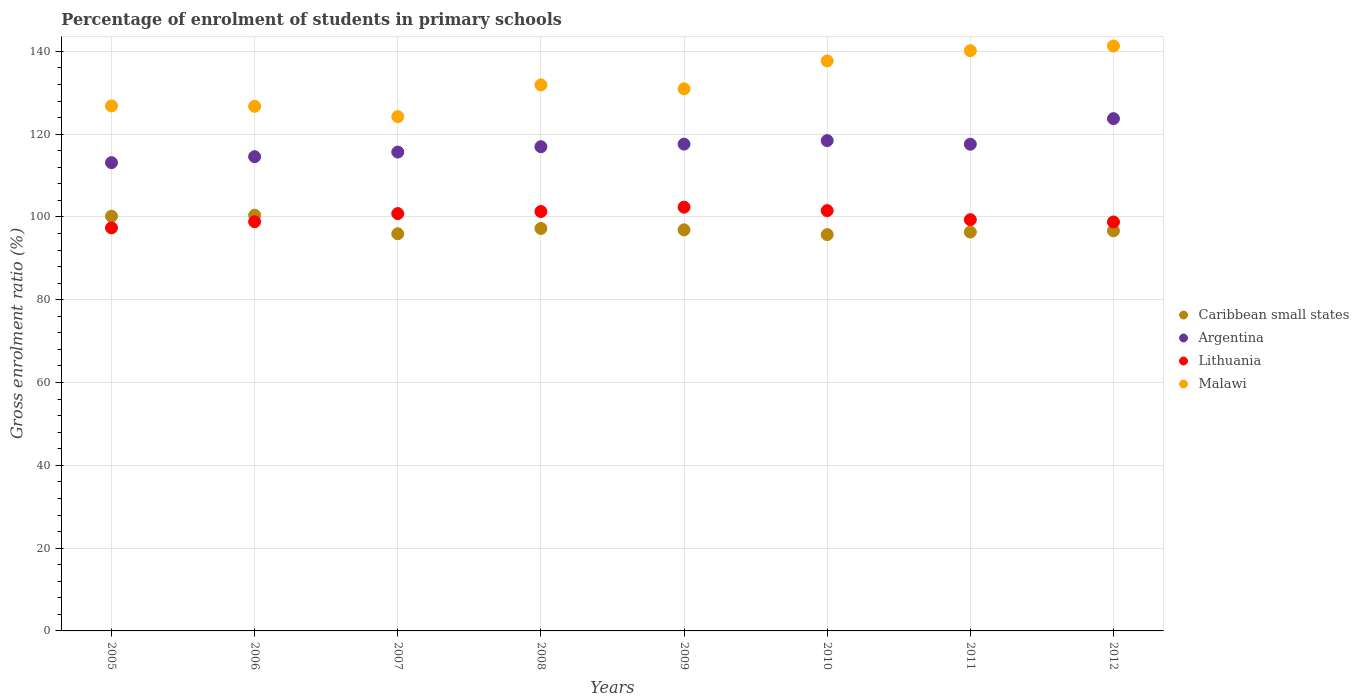What is the percentage of students enrolled in primary schools in Malawi in 2012?
Give a very brief answer. 141.29. Across all years, what is the maximum percentage of students enrolled in primary schools in Argentina?
Your response must be concise. 123.75. Across all years, what is the minimum percentage of students enrolled in primary schools in Malawi?
Keep it short and to the point. 124.23. What is the total percentage of students enrolled in primary schools in Malawi in the graph?
Your answer should be very brief. 1059.76. What is the difference between the percentage of students enrolled in primary schools in Malawi in 2005 and that in 2011?
Provide a succinct answer. -13.33. What is the difference between the percentage of students enrolled in primary schools in Lithuania in 2009 and the percentage of students enrolled in primary schools in Malawi in 2008?
Your answer should be compact. -29.54. What is the average percentage of students enrolled in primary schools in Argentina per year?
Keep it short and to the point. 117.21. In the year 2012, what is the difference between the percentage of students enrolled in primary schools in Lithuania and percentage of students enrolled in primary schools in Malawi?
Keep it short and to the point. -42.51. In how many years, is the percentage of students enrolled in primary schools in Argentina greater than 84 %?
Offer a terse response. 8. What is the ratio of the percentage of students enrolled in primary schools in Caribbean small states in 2009 to that in 2010?
Give a very brief answer. 1.01. What is the difference between the highest and the second highest percentage of students enrolled in primary schools in Caribbean small states?
Make the answer very short. 0.23. What is the difference between the highest and the lowest percentage of students enrolled in primary schools in Malawi?
Ensure brevity in your answer.  17.06. Is it the case that in every year, the sum of the percentage of students enrolled in primary schools in Malawi and percentage of students enrolled in primary schools in Caribbean small states  is greater than the sum of percentage of students enrolled in primary schools in Argentina and percentage of students enrolled in primary schools in Lithuania?
Make the answer very short. No. Is the percentage of students enrolled in primary schools in Lithuania strictly greater than the percentage of students enrolled in primary schools in Malawi over the years?
Give a very brief answer. No. How many years are there in the graph?
Make the answer very short. 8. What is the difference between two consecutive major ticks on the Y-axis?
Ensure brevity in your answer.  20. Where does the legend appear in the graph?
Provide a succinct answer. Center right. How many legend labels are there?
Keep it short and to the point. 4. How are the legend labels stacked?
Offer a terse response. Vertical. What is the title of the graph?
Your answer should be compact. Percentage of enrolment of students in primary schools. What is the Gross enrolment ratio (%) in Caribbean small states in 2005?
Provide a short and direct response. 100.18. What is the Gross enrolment ratio (%) of Argentina in 2005?
Keep it short and to the point. 113.11. What is the Gross enrolment ratio (%) in Lithuania in 2005?
Your response must be concise. 97.36. What is the Gross enrolment ratio (%) of Malawi in 2005?
Provide a short and direct response. 126.82. What is the Gross enrolment ratio (%) in Caribbean small states in 2006?
Provide a short and direct response. 100.41. What is the Gross enrolment ratio (%) in Argentina in 2006?
Your response must be concise. 114.55. What is the Gross enrolment ratio (%) of Lithuania in 2006?
Your answer should be very brief. 98.85. What is the Gross enrolment ratio (%) of Malawi in 2006?
Offer a very short reply. 126.73. What is the Gross enrolment ratio (%) of Caribbean small states in 2007?
Your answer should be compact. 95.94. What is the Gross enrolment ratio (%) of Argentina in 2007?
Your answer should be very brief. 115.67. What is the Gross enrolment ratio (%) of Lithuania in 2007?
Make the answer very short. 100.81. What is the Gross enrolment ratio (%) in Malawi in 2007?
Your answer should be compact. 124.23. What is the Gross enrolment ratio (%) of Caribbean small states in 2008?
Make the answer very short. 97.22. What is the Gross enrolment ratio (%) in Argentina in 2008?
Keep it short and to the point. 116.96. What is the Gross enrolment ratio (%) in Lithuania in 2008?
Give a very brief answer. 101.31. What is the Gross enrolment ratio (%) in Malawi in 2008?
Give a very brief answer. 131.9. What is the Gross enrolment ratio (%) of Caribbean small states in 2009?
Your answer should be very brief. 96.88. What is the Gross enrolment ratio (%) of Argentina in 2009?
Your response must be concise. 117.59. What is the Gross enrolment ratio (%) in Lithuania in 2009?
Provide a short and direct response. 102.36. What is the Gross enrolment ratio (%) in Malawi in 2009?
Your answer should be compact. 130.95. What is the Gross enrolment ratio (%) in Caribbean small states in 2010?
Provide a short and direct response. 95.74. What is the Gross enrolment ratio (%) in Argentina in 2010?
Provide a succinct answer. 118.43. What is the Gross enrolment ratio (%) of Lithuania in 2010?
Keep it short and to the point. 101.52. What is the Gross enrolment ratio (%) in Malawi in 2010?
Make the answer very short. 137.69. What is the Gross enrolment ratio (%) of Caribbean small states in 2011?
Your answer should be very brief. 96.34. What is the Gross enrolment ratio (%) of Argentina in 2011?
Your answer should be very brief. 117.57. What is the Gross enrolment ratio (%) in Lithuania in 2011?
Your answer should be compact. 99.33. What is the Gross enrolment ratio (%) of Malawi in 2011?
Offer a very short reply. 140.15. What is the Gross enrolment ratio (%) of Caribbean small states in 2012?
Offer a very short reply. 96.65. What is the Gross enrolment ratio (%) of Argentina in 2012?
Give a very brief answer. 123.75. What is the Gross enrolment ratio (%) of Lithuania in 2012?
Keep it short and to the point. 98.78. What is the Gross enrolment ratio (%) of Malawi in 2012?
Your response must be concise. 141.29. Across all years, what is the maximum Gross enrolment ratio (%) of Caribbean small states?
Your answer should be compact. 100.41. Across all years, what is the maximum Gross enrolment ratio (%) in Argentina?
Give a very brief answer. 123.75. Across all years, what is the maximum Gross enrolment ratio (%) of Lithuania?
Offer a terse response. 102.36. Across all years, what is the maximum Gross enrolment ratio (%) of Malawi?
Offer a very short reply. 141.29. Across all years, what is the minimum Gross enrolment ratio (%) in Caribbean small states?
Your answer should be very brief. 95.74. Across all years, what is the minimum Gross enrolment ratio (%) in Argentina?
Give a very brief answer. 113.11. Across all years, what is the minimum Gross enrolment ratio (%) in Lithuania?
Offer a very short reply. 97.36. Across all years, what is the minimum Gross enrolment ratio (%) of Malawi?
Provide a succinct answer. 124.23. What is the total Gross enrolment ratio (%) in Caribbean small states in the graph?
Your answer should be compact. 779.36. What is the total Gross enrolment ratio (%) in Argentina in the graph?
Your answer should be very brief. 937.64. What is the total Gross enrolment ratio (%) in Lithuania in the graph?
Your answer should be compact. 800.33. What is the total Gross enrolment ratio (%) in Malawi in the graph?
Keep it short and to the point. 1059.76. What is the difference between the Gross enrolment ratio (%) of Caribbean small states in 2005 and that in 2006?
Offer a terse response. -0.23. What is the difference between the Gross enrolment ratio (%) of Argentina in 2005 and that in 2006?
Your answer should be compact. -1.44. What is the difference between the Gross enrolment ratio (%) in Lithuania in 2005 and that in 2006?
Give a very brief answer. -1.49. What is the difference between the Gross enrolment ratio (%) of Malawi in 2005 and that in 2006?
Make the answer very short. 0.09. What is the difference between the Gross enrolment ratio (%) of Caribbean small states in 2005 and that in 2007?
Provide a short and direct response. 4.24. What is the difference between the Gross enrolment ratio (%) of Argentina in 2005 and that in 2007?
Your answer should be compact. -2.56. What is the difference between the Gross enrolment ratio (%) of Lithuania in 2005 and that in 2007?
Make the answer very short. -3.45. What is the difference between the Gross enrolment ratio (%) in Malawi in 2005 and that in 2007?
Your response must be concise. 2.59. What is the difference between the Gross enrolment ratio (%) in Caribbean small states in 2005 and that in 2008?
Offer a terse response. 2.96. What is the difference between the Gross enrolment ratio (%) in Argentina in 2005 and that in 2008?
Offer a very short reply. -3.85. What is the difference between the Gross enrolment ratio (%) in Lithuania in 2005 and that in 2008?
Provide a short and direct response. -3.95. What is the difference between the Gross enrolment ratio (%) of Malawi in 2005 and that in 2008?
Keep it short and to the point. -5.08. What is the difference between the Gross enrolment ratio (%) of Caribbean small states in 2005 and that in 2009?
Offer a terse response. 3.3. What is the difference between the Gross enrolment ratio (%) of Argentina in 2005 and that in 2009?
Your answer should be compact. -4.48. What is the difference between the Gross enrolment ratio (%) of Lithuania in 2005 and that in 2009?
Ensure brevity in your answer.  -5. What is the difference between the Gross enrolment ratio (%) in Malawi in 2005 and that in 2009?
Ensure brevity in your answer.  -4.13. What is the difference between the Gross enrolment ratio (%) of Caribbean small states in 2005 and that in 2010?
Make the answer very short. 4.44. What is the difference between the Gross enrolment ratio (%) in Argentina in 2005 and that in 2010?
Make the answer very short. -5.32. What is the difference between the Gross enrolment ratio (%) in Lithuania in 2005 and that in 2010?
Your answer should be very brief. -4.16. What is the difference between the Gross enrolment ratio (%) of Malawi in 2005 and that in 2010?
Provide a succinct answer. -10.87. What is the difference between the Gross enrolment ratio (%) in Caribbean small states in 2005 and that in 2011?
Give a very brief answer. 3.84. What is the difference between the Gross enrolment ratio (%) of Argentina in 2005 and that in 2011?
Your response must be concise. -4.45. What is the difference between the Gross enrolment ratio (%) in Lithuania in 2005 and that in 2011?
Ensure brevity in your answer.  -1.97. What is the difference between the Gross enrolment ratio (%) in Malawi in 2005 and that in 2011?
Give a very brief answer. -13.33. What is the difference between the Gross enrolment ratio (%) of Caribbean small states in 2005 and that in 2012?
Ensure brevity in your answer.  3.53. What is the difference between the Gross enrolment ratio (%) of Argentina in 2005 and that in 2012?
Provide a succinct answer. -10.64. What is the difference between the Gross enrolment ratio (%) of Lithuania in 2005 and that in 2012?
Your response must be concise. -1.42. What is the difference between the Gross enrolment ratio (%) in Malawi in 2005 and that in 2012?
Your response must be concise. -14.47. What is the difference between the Gross enrolment ratio (%) in Caribbean small states in 2006 and that in 2007?
Provide a short and direct response. 4.47. What is the difference between the Gross enrolment ratio (%) of Argentina in 2006 and that in 2007?
Keep it short and to the point. -1.12. What is the difference between the Gross enrolment ratio (%) in Lithuania in 2006 and that in 2007?
Make the answer very short. -1.96. What is the difference between the Gross enrolment ratio (%) of Malawi in 2006 and that in 2007?
Keep it short and to the point. 2.5. What is the difference between the Gross enrolment ratio (%) in Caribbean small states in 2006 and that in 2008?
Make the answer very short. 3.19. What is the difference between the Gross enrolment ratio (%) in Argentina in 2006 and that in 2008?
Your answer should be compact. -2.41. What is the difference between the Gross enrolment ratio (%) of Lithuania in 2006 and that in 2008?
Provide a short and direct response. -2.46. What is the difference between the Gross enrolment ratio (%) in Malawi in 2006 and that in 2008?
Make the answer very short. -5.17. What is the difference between the Gross enrolment ratio (%) of Caribbean small states in 2006 and that in 2009?
Give a very brief answer. 3.53. What is the difference between the Gross enrolment ratio (%) in Argentina in 2006 and that in 2009?
Your answer should be compact. -3.04. What is the difference between the Gross enrolment ratio (%) of Lithuania in 2006 and that in 2009?
Your response must be concise. -3.51. What is the difference between the Gross enrolment ratio (%) of Malawi in 2006 and that in 2009?
Provide a short and direct response. -4.22. What is the difference between the Gross enrolment ratio (%) in Caribbean small states in 2006 and that in 2010?
Offer a very short reply. 4.68. What is the difference between the Gross enrolment ratio (%) in Argentina in 2006 and that in 2010?
Offer a terse response. -3.88. What is the difference between the Gross enrolment ratio (%) in Lithuania in 2006 and that in 2010?
Ensure brevity in your answer.  -2.67. What is the difference between the Gross enrolment ratio (%) of Malawi in 2006 and that in 2010?
Offer a very short reply. -10.96. What is the difference between the Gross enrolment ratio (%) of Caribbean small states in 2006 and that in 2011?
Your answer should be compact. 4.07. What is the difference between the Gross enrolment ratio (%) in Argentina in 2006 and that in 2011?
Your answer should be compact. -3.01. What is the difference between the Gross enrolment ratio (%) of Lithuania in 2006 and that in 2011?
Ensure brevity in your answer.  -0.48. What is the difference between the Gross enrolment ratio (%) in Malawi in 2006 and that in 2011?
Provide a succinct answer. -13.43. What is the difference between the Gross enrolment ratio (%) of Caribbean small states in 2006 and that in 2012?
Keep it short and to the point. 3.76. What is the difference between the Gross enrolment ratio (%) in Argentina in 2006 and that in 2012?
Provide a succinct answer. -9.19. What is the difference between the Gross enrolment ratio (%) in Lithuania in 2006 and that in 2012?
Your answer should be compact. 0.07. What is the difference between the Gross enrolment ratio (%) in Malawi in 2006 and that in 2012?
Your response must be concise. -14.56. What is the difference between the Gross enrolment ratio (%) in Caribbean small states in 2007 and that in 2008?
Provide a short and direct response. -1.28. What is the difference between the Gross enrolment ratio (%) in Argentina in 2007 and that in 2008?
Your answer should be compact. -1.29. What is the difference between the Gross enrolment ratio (%) of Lithuania in 2007 and that in 2008?
Keep it short and to the point. -0.5. What is the difference between the Gross enrolment ratio (%) in Malawi in 2007 and that in 2008?
Your answer should be very brief. -7.67. What is the difference between the Gross enrolment ratio (%) in Caribbean small states in 2007 and that in 2009?
Ensure brevity in your answer.  -0.94. What is the difference between the Gross enrolment ratio (%) of Argentina in 2007 and that in 2009?
Your response must be concise. -1.92. What is the difference between the Gross enrolment ratio (%) of Lithuania in 2007 and that in 2009?
Give a very brief answer. -1.55. What is the difference between the Gross enrolment ratio (%) of Malawi in 2007 and that in 2009?
Ensure brevity in your answer.  -6.72. What is the difference between the Gross enrolment ratio (%) in Caribbean small states in 2007 and that in 2010?
Offer a terse response. 0.2. What is the difference between the Gross enrolment ratio (%) of Argentina in 2007 and that in 2010?
Give a very brief answer. -2.76. What is the difference between the Gross enrolment ratio (%) of Lithuania in 2007 and that in 2010?
Make the answer very short. -0.71. What is the difference between the Gross enrolment ratio (%) in Malawi in 2007 and that in 2010?
Provide a succinct answer. -13.46. What is the difference between the Gross enrolment ratio (%) in Caribbean small states in 2007 and that in 2011?
Provide a short and direct response. -0.4. What is the difference between the Gross enrolment ratio (%) in Argentina in 2007 and that in 2011?
Make the answer very short. -1.89. What is the difference between the Gross enrolment ratio (%) of Lithuania in 2007 and that in 2011?
Provide a succinct answer. 1.48. What is the difference between the Gross enrolment ratio (%) in Malawi in 2007 and that in 2011?
Provide a short and direct response. -15.93. What is the difference between the Gross enrolment ratio (%) in Caribbean small states in 2007 and that in 2012?
Provide a short and direct response. -0.71. What is the difference between the Gross enrolment ratio (%) of Argentina in 2007 and that in 2012?
Your answer should be very brief. -8.07. What is the difference between the Gross enrolment ratio (%) in Lithuania in 2007 and that in 2012?
Your response must be concise. 2.03. What is the difference between the Gross enrolment ratio (%) in Malawi in 2007 and that in 2012?
Keep it short and to the point. -17.06. What is the difference between the Gross enrolment ratio (%) in Caribbean small states in 2008 and that in 2009?
Make the answer very short. 0.34. What is the difference between the Gross enrolment ratio (%) of Argentina in 2008 and that in 2009?
Provide a succinct answer. -0.63. What is the difference between the Gross enrolment ratio (%) in Lithuania in 2008 and that in 2009?
Ensure brevity in your answer.  -1.05. What is the difference between the Gross enrolment ratio (%) of Malawi in 2008 and that in 2009?
Offer a terse response. 0.95. What is the difference between the Gross enrolment ratio (%) of Caribbean small states in 2008 and that in 2010?
Offer a terse response. 1.48. What is the difference between the Gross enrolment ratio (%) in Argentina in 2008 and that in 2010?
Offer a terse response. -1.47. What is the difference between the Gross enrolment ratio (%) in Lithuania in 2008 and that in 2010?
Provide a succinct answer. -0.21. What is the difference between the Gross enrolment ratio (%) of Malawi in 2008 and that in 2010?
Your response must be concise. -5.79. What is the difference between the Gross enrolment ratio (%) in Caribbean small states in 2008 and that in 2011?
Provide a short and direct response. 0.88. What is the difference between the Gross enrolment ratio (%) in Argentina in 2008 and that in 2011?
Keep it short and to the point. -0.6. What is the difference between the Gross enrolment ratio (%) in Lithuania in 2008 and that in 2011?
Give a very brief answer. 1.98. What is the difference between the Gross enrolment ratio (%) of Malawi in 2008 and that in 2011?
Make the answer very short. -8.26. What is the difference between the Gross enrolment ratio (%) in Caribbean small states in 2008 and that in 2012?
Ensure brevity in your answer.  0.57. What is the difference between the Gross enrolment ratio (%) in Argentina in 2008 and that in 2012?
Provide a short and direct response. -6.78. What is the difference between the Gross enrolment ratio (%) of Lithuania in 2008 and that in 2012?
Offer a very short reply. 2.53. What is the difference between the Gross enrolment ratio (%) in Malawi in 2008 and that in 2012?
Provide a short and direct response. -9.39. What is the difference between the Gross enrolment ratio (%) in Caribbean small states in 2009 and that in 2010?
Ensure brevity in your answer.  1.14. What is the difference between the Gross enrolment ratio (%) of Argentina in 2009 and that in 2010?
Give a very brief answer. -0.84. What is the difference between the Gross enrolment ratio (%) in Lithuania in 2009 and that in 2010?
Provide a short and direct response. 0.83. What is the difference between the Gross enrolment ratio (%) of Malawi in 2009 and that in 2010?
Provide a short and direct response. -6.74. What is the difference between the Gross enrolment ratio (%) in Caribbean small states in 2009 and that in 2011?
Offer a terse response. 0.53. What is the difference between the Gross enrolment ratio (%) of Argentina in 2009 and that in 2011?
Make the answer very short. 0.03. What is the difference between the Gross enrolment ratio (%) of Lithuania in 2009 and that in 2011?
Give a very brief answer. 3.02. What is the difference between the Gross enrolment ratio (%) of Malawi in 2009 and that in 2011?
Offer a very short reply. -9.21. What is the difference between the Gross enrolment ratio (%) in Caribbean small states in 2009 and that in 2012?
Your answer should be very brief. 0.23. What is the difference between the Gross enrolment ratio (%) of Argentina in 2009 and that in 2012?
Provide a short and direct response. -6.15. What is the difference between the Gross enrolment ratio (%) of Lithuania in 2009 and that in 2012?
Give a very brief answer. 3.58. What is the difference between the Gross enrolment ratio (%) in Malawi in 2009 and that in 2012?
Your answer should be very brief. -10.34. What is the difference between the Gross enrolment ratio (%) in Caribbean small states in 2010 and that in 2011?
Your answer should be very brief. -0.61. What is the difference between the Gross enrolment ratio (%) in Argentina in 2010 and that in 2011?
Your response must be concise. 0.87. What is the difference between the Gross enrolment ratio (%) of Lithuania in 2010 and that in 2011?
Your answer should be very brief. 2.19. What is the difference between the Gross enrolment ratio (%) of Malawi in 2010 and that in 2011?
Your answer should be compact. -2.47. What is the difference between the Gross enrolment ratio (%) of Caribbean small states in 2010 and that in 2012?
Offer a very short reply. -0.92. What is the difference between the Gross enrolment ratio (%) of Argentina in 2010 and that in 2012?
Give a very brief answer. -5.31. What is the difference between the Gross enrolment ratio (%) in Lithuania in 2010 and that in 2012?
Your response must be concise. 2.74. What is the difference between the Gross enrolment ratio (%) in Malawi in 2010 and that in 2012?
Give a very brief answer. -3.6. What is the difference between the Gross enrolment ratio (%) in Caribbean small states in 2011 and that in 2012?
Give a very brief answer. -0.31. What is the difference between the Gross enrolment ratio (%) in Argentina in 2011 and that in 2012?
Your answer should be very brief. -6.18. What is the difference between the Gross enrolment ratio (%) in Lithuania in 2011 and that in 2012?
Provide a succinct answer. 0.55. What is the difference between the Gross enrolment ratio (%) of Malawi in 2011 and that in 2012?
Your answer should be compact. -1.14. What is the difference between the Gross enrolment ratio (%) of Caribbean small states in 2005 and the Gross enrolment ratio (%) of Argentina in 2006?
Ensure brevity in your answer.  -14.37. What is the difference between the Gross enrolment ratio (%) in Caribbean small states in 2005 and the Gross enrolment ratio (%) in Lithuania in 2006?
Keep it short and to the point. 1.33. What is the difference between the Gross enrolment ratio (%) in Caribbean small states in 2005 and the Gross enrolment ratio (%) in Malawi in 2006?
Provide a succinct answer. -26.55. What is the difference between the Gross enrolment ratio (%) of Argentina in 2005 and the Gross enrolment ratio (%) of Lithuania in 2006?
Your response must be concise. 14.26. What is the difference between the Gross enrolment ratio (%) in Argentina in 2005 and the Gross enrolment ratio (%) in Malawi in 2006?
Provide a short and direct response. -13.62. What is the difference between the Gross enrolment ratio (%) of Lithuania in 2005 and the Gross enrolment ratio (%) of Malawi in 2006?
Ensure brevity in your answer.  -29.37. What is the difference between the Gross enrolment ratio (%) of Caribbean small states in 2005 and the Gross enrolment ratio (%) of Argentina in 2007?
Your answer should be compact. -15.49. What is the difference between the Gross enrolment ratio (%) in Caribbean small states in 2005 and the Gross enrolment ratio (%) in Lithuania in 2007?
Make the answer very short. -0.63. What is the difference between the Gross enrolment ratio (%) in Caribbean small states in 2005 and the Gross enrolment ratio (%) in Malawi in 2007?
Ensure brevity in your answer.  -24.05. What is the difference between the Gross enrolment ratio (%) in Argentina in 2005 and the Gross enrolment ratio (%) in Lithuania in 2007?
Keep it short and to the point. 12.3. What is the difference between the Gross enrolment ratio (%) in Argentina in 2005 and the Gross enrolment ratio (%) in Malawi in 2007?
Give a very brief answer. -11.12. What is the difference between the Gross enrolment ratio (%) of Lithuania in 2005 and the Gross enrolment ratio (%) of Malawi in 2007?
Your response must be concise. -26.87. What is the difference between the Gross enrolment ratio (%) of Caribbean small states in 2005 and the Gross enrolment ratio (%) of Argentina in 2008?
Keep it short and to the point. -16.79. What is the difference between the Gross enrolment ratio (%) in Caribbean small states in 2005 and the Gross enrolment ratio (%) in Lithuania in 2008?
Provide a short and direct response. -1.13. What is the difference between the Gross enrolment ratio (%) in Caribbean small states in 2005 and the Gross enrolment ratio (%) in Malawi in 2008?
Keep it short and to the point. -31.72. What is the difference between the Gross enrolment ratio (%) in Argentina in 2005 and the Gross enrolment ratio (%) in Lithuania in 2008?
Provide a succinct answer. 11.8. What is the difference between the Gross enrolment ratio (%) in Argentina in 2005 and the Gross enrolment ratio (%) in Malawi in 2008?
Your answer should be compact. -18.79. What is the difference between the Gross enrolment ratio (%) in Lithuania in 2005 and the Gross enrolment ratio (%) in Malawi in 2008?
Your answer should be compact. -34.54. What is the difference between the Gross enrolment ratio (%) in Caribbean small states in 2005 and the Gross enrolment ratio (%) in Argentina in 2009?
Give a very brief answer. -17.41. What is the difference between the Gross enrolment ratio (%) of Caribbean small states in 2005 and the Gross enrolment ratio (%) of Lithuania in 2009?
Offer a very short reply. -2.18. What is the difference between the Gross enrolment ratio (%) in Caribbean small states in 2005 and the Gross enrolment ratio (%) in Malawi in 2009?
Offer a very short reply. -30.77. What is the difference between the Gross enrolment ratio (%) in Argentina in 2005 and the Gross enrolment ratio (%) in Lithuania in 2009?
Keep it short and to the point. 10.75. What is the difference between the Gross enrolment ratio (%) of Argentina in 2005 and the Gross enrolment ratio (%) of Malawi in 2009?
Your response must be concise. -17.84. What is the difference between the Gross enrolment ratio (%) in Lithuania in 2005 and the Gross enrolment ratio (%) in Malawi in 2009?
Your answer should be very brief. -33.59. What is the difference between the Gross enrolment ratio (%) in Caribbean small states in 2005 and the Gross enrolment ratio (%) in Argentina in 2010?
Provide a succinct answer. -18.26. What is the difference between the Gross enrolment ratio (%) of Caribbean small states in 2005 and the Gross enrolment ratio (%) of Lithuania in 2010?
Keep it short and to the point. -1.34. What is the difference between the Gross enrolment ratio (%) in Caribbean small states in 2005 and the Gross enrolment ratio (%) in Malawi in 2010?
Offer a terse response. -37.51. What is the difference between the Gross enrolment ratio (%) of Argentina in 2005 and the Gross enrolment ratio (%) of Lithuania in 2010?
Your answer should be compact. 11.59. What is the difference between the Gross enrolment ratio (%) of Argentina in 2005 and the Gross enrolment ratio (%) of Malawi in 2010?
Make the answer very short. -24.58. What is the difference between the Gross enrolment ratio (%) in Lithuania in 2005 and the Gross enrolment ratio (%) in Malawi in 2010?
Keep it short and to the point. -40.33. What is the difference between the Gross enrolment ratio (%) in Caribbean small states in 2005 and the Gross enrolment ratio (%) in Argentina in 2011?
Make the answer very short. -17.39. What is the difference between the Gross enrolment ratio (%) of Caribbean small states in 2005 and the Gross enrolment ratio (%) of Lithuania in 2011?
Ensure brevity in your answer.  0.85. What is the difference between the Gross enrolment ratio (%) of Caribbean small states in 2005 and the Gross enrolment ratio (%) of Malawi in 2011?
Ensure brevity in your answer.  -39.98. What is the difference between the Gross enrolment ratio (%) in Argentina in 2005 and the Gross enrolment ratio (%) in Lithuania in 2011?
Your answer should be very brief. 13.78. What is the difference between the Gross enrolment ratio (%) of Argentina in 2005 and the Gross enrolment ratio (%) of Malawi in 2011?
Provide a short and direct response. -27.04. What is the difference between the Gross enrolment ratio (%) of Lithuania in 2005 and the Gross enrolment ratio (%) of Malawi in 2011?
Ensure brevity in your answer.  -42.8. What is the difference between the Gross enrolment ratio (%) in Caribbean small states in 2005 and the Gross enrolment ratio (%) in Argentina in 2012?
Your answer should be very brief. -23.57. What is the difference between the Gross enrolment ratio (%) of Caribbean small states in 2005 and the Gross enrolment ratio (%) of Lithuania in 2012?
Make the answer very short. 1.4. What is the difference between the Gross enrolment ratio (%) in Caribbean small states in 2005 and the Gross enrolment ratio (%) in Malawi in 2012?
Keep it short and to the point. -41.11. What is the difference between the Gross enrolment ratio (%) in Argentina in 2005 and the Gross enrolment ratio (%) in Lithuania in 2012?
Offer a terse response. 14.33. What is the difference between the Gross enrolment ratio (%) in Argentina in 2005 and the Gross enrolment ratio (%) in Malawi in 2012?
Make the answer very short. -28.18. What is the difference between the Gross enrolment ratio (%) of Lithuania in 2005 and the Gross enrolment ratio (%) of Malawi in 2012?
Your answer should be compact. -43.93. What is the difference between the Gross enrolment ratio (%) in Caribbean small states in 2006 and the Gross enrolment ratio (%) in Argentina in 2007?
Give a very brief answer. -15.26. What is the difference between the Gross enrolment ratio (%) of Caribbean small states in 2006 and the Gross enrolment ratio (%) of Lithuania in 2007?
Keep it short and to the point. -0.4. What is the difference between the Gross enrolment ratio (%) in Caribbean small states in 2006 and the Gross enrolment ratio (%) in Malawi in 2007?
Make the answer very short. -23.81. What is the difference between the Gross enrolment ratio (%) of Argentina in 2006 and the Gross enrolment ratio (%) of Lithuania in 2007?
Provide a succinct answer. 13.74. What is the difference between the Gross enrolment ratio (%) in Argentina in 2006 and the Gross enrolment ratio (%) in Malawi in 2007?
Provide a short and direct response. -9.67. What is the difference between the Gross enrolment ratio (%) in Lithuania in 2006 and the Gross enrolment ratio (%) in Malawi in 2007?
Keep it short and to the point. -25.38. What is the difference between the Gross enrolment ratio (%) of Caribbean small states in 2006 and the Gross enrolment ratio (%) of Argentina in 2008?
Give a very brief answer. -16.55. What is the difference between the Gross enrolment ratio (%) in Caribbean small states in 2006 and the Gross enrolment ratio (%) in Lithuania in 2008?
Keep it short and to the point. -0.9. What is the difference between the Gross enrolment ratio (%) of Caribbean small states in 2006 and the Gross enrolment ratio (%) of Malawi in 2008?
Ensure brevity in your answer.  -31.48. What is the difference between the Gross enrolment ratio (%) in Argentina in 2006 and the Gross enrolment ratio (%) in Lithuania in 2008?
Provide a succinct answer. 13.24. What is the difference between the Gross enrolment ratio (%) in Argentina in 2006 and the Gross enrolment ratio (%) in Malawi in 2008?
Provide a short and direct response. -17.34. What is the difference between the Gross enrolment ratio (%) in Lithuania in 2006 and the Gross enrolment ratio (%) in Malawi in 2008?
Provide a short and direct response. -33.05. What is the difference between the Gross enrolment ratio (%) of Caribbean small states in 2006 and the Gross enrolment ratio (%) of Argentina in 2009?
Ensure brevity in your answer.  -17.18. What is the difference between the Gross enrolment ratio (%) in Caribbean small states in 2006 and the Gross enrolment ratio (%) in Lithuania in 2009?
Your response must be concise. -1.95. What is the difference between the Gross enrolment ratio (%) in Caribbean small states in 2006 and the Gross enrolment ratio (%) in Malawi in 2009?
Provide a short and direct response. -30.54. What is the difference between the Gross enrolment ratio (%) of Argentina in 2006 and the Gross enrolment ratio (%) of Lithuania in 2009?
Your answer should be very brief. 12.2. What is the difference between the Gross enrolment ratio (%) of Argentina in 2006 and the Gross enrolment ratio (%) of Malawi in 2009?
Offer a terse response. -16.39. What is the difference between the Gross enrolment ratio (%) in Lithuania in 2006 and the Gross enrolment ratio (%) in Malawi in 2009?
Your response must be concise. -32.1. What is the difference between the Gross enrolment ratio (%) in Caribbean small states in 2006 and the Gross enrolment ratio (%) in Argentina in 2010?
Offer a terse response. -18.02. What is the difference between the Gross enrolment ratio (%) of Caribbean small states in 2006 and the Gross enrolment ratio (%) of Lithuania in 2010?
Give a very brief answer. -1.11. What is the difference between the Gross enrolment ratio (%) in Caribbean small states in 2006 and the Gross enrolment ratio (%) in Malawi in 2010?
Provide a succinct answer. -37.28. What is the difference between the Gross enrolment ratio (%) of Argentina in 2006 and the Gross enrolment ratio (%) of Lithuania in 2010?
Your answer should be compact. 13.03. What is the difference between the Gross enrolment ratio (%) in Argentina in 2006 and the Gross enrolment ratio (%) in Malawi in 2010?
Your answer should be compact. -23.13. What is the difference between the Gross enrolment ratio (%) in Lithuania in 2006 and the Gross enrolment ratio (%) in Malawi in 2010?
Give a very brief answer. -38.84. What is the difference between the Gross enrolment ratio (%) in Caribbean small states in 2006 and the Gross enrolment ratio (%) in Argentina in 2011?
Your answer should be very brief. -17.15. What is the difference between the Gross enrolment ratio (%) of Caribbean small states in 2006 and the Gross enrolment ratio (%) of Lithuania in 2011?
Provide a succinct answer. 1.08. What is the difference between the Gross enrolment ratio (%) of Caribbean small states in 2006 and the Gross enrolment ratio (%) of Malawi in 2011?
Your response must be concise. -39.74. What is the difference between the Gross enrolment ratio (%) in Argentina in 2006 and the Gross enrolment ratio (%) in Lithuania in 2011?
Offer a terse response. 15.22. What is the difference between the Gross enrolment ratio (%) in Argentina in 2006 and the Gross enrolment ratio (%) in Malawi in 2011?
Your answer should be compact. -25.6. What is the difference between the Gross enrolment ratio (%) in Lithuania in 2006 and the Gross enrolment ratio (%) in Malawi in 2011?
Offer a terse response. -41.31. What is the difference between the Gross enrolment ratio (%) of Caribbean small states in 2006 and the Gross enrolment ratio (%) of Argentina in 2012?
Your answer should be very brief. -23.33. What is the difference between the Gross enrolment ratio (%) of Caribbean small states in 2006 and the Gross enrolment ratio (%) of Lithuania in 2012?
Offer a terse response. 1.63. What is the difference between the Gross enrolment ratio (%) of Caribbean small states in 2006 and the Gross enrolment ratio (%) of Malawi in 2012?
Your response must be concise. -40.88. What is the difference between the Gross enrolment ratio (%) of Argentina in 2006 and the Gross enrolment ratio (%) of Lithuania in 2012?
Make the answer very short. 15.77. What is the difference between the Gross enrolment ratio (%) in Argentina in 2006 and the Gross enrolment ratio (%) in Malawi in 2012?
Provide a short and direct response. -26.74. What is the difference between the Gross enrolment ratio (%) in Lithuania in 2006 and the Gross enrolment ratio (%) in Malawi in 2012?
Give a very brief answer. -42.44. What is the difference between the Gross enrolment ratio (%) of Caribbean small states in 2007 and the Gross enrolment ratio (%) of Argentina in 2008?
Make the answer very short. -21.02. What is the difference between the Gross enrolment ratio (%) of Caribbean small states in 2007 and the Gross enrolment ratio (%) of Lithuania in 2008?
Keep it short and to the point. -5.37. What is the difference between the Gross enrolment ratio (%) of Caribbean small states in 2007 and the Gross enrolment ratio (%) of Malawi in 2008?
Your response must be concise. -35.96. What is the difference between the Gross enrolment ratio (%) in Argentina in 2007 and the Gross enrolment ratio (%) in Lithuania in 2008?
Ensure brevity in your answer.  14.36. What is the difference between the Gross enrolment ratio (%) in Argentina in 2007 and the Gross enrolment ratio (%) in Malawi in 2008?
Your answer should be very brief. -16.22. What is the difference between the Gross enrolment ratio (%) of Lithuania in 2007 and the Gross enrolment ratio (%) of Malawi in 2008?
Provide a succinct answer. -31.09. What is the difference between the Gross enrolment ratio (%) of Caribbean small states in 2007 and the Gross enrolment ratio (%) of Argentina in 2009?
Make the answer very short. -21.65. What is the difference between the Gross enrolment ratio (%) in Caribbean small states in 2007 and the Gross enrolment ratio (%) in Lithuania in 2009?
Offer a very short reply. -6.42. What is the difference between the Gross enrolment ratio (%) of Caribbean small states in 2007 and the Gross enrolment ratio (%) of Malawi in 2009?
Your answer should be compact. -35.01. What is the difference between the Gross enrolment ratio (%) of Argentina in 2007 and the Gross enrolment ratio (%) of Lithuania in 2009?
Your response must be concise. 13.31. What is the difference between the Gross enrolment ratio (%) in Argentina in 2007 and the Gross enrolment ratio (%) in Malawi in 2009?
Your answer should be compact. -15.28. What is the difference between the Gross enrolment ratio (%) in Lithuania in 2007 and the Gross enrolment ratio (%) in Malawi in 2009?
Provide a short and direct response. -30.14. What is the difference between the Gross enrolment ratio (%) of Caribbean small states in 2007 and the Gross enrolment ratio (%) of Argentina in 2010?
Offer a very short reply. -22.49. What is the difference between the Gross enrolment ratio (%) of Caribbean small states in 2007 and the Gross enrolment ratio (%) of Lithuania in 2010?
Provide a short and direct response. -5.58. What is the difference between the Gross enrolment ratio (%) of Caribbean small states in 2007 and the Gross enrolment ratio (%) of Malawi in 2010?
Make the answer very short. -41.75. What is the difference between the Gross enrolment ratio (%) in Argentina in 2007 and the Gross enrolment ratio (%) in Lithuania in 2010?
Ensure brevity in your answer.  14.15. What is the difference between the Gross enrolment ratio (%) in Argentina in 2007 and the Gross enrolment ratio (%) in Malawi in 2010?
Give a very brief answer. -22.02. What is the difference between the Gross enrolment ratio (%) in Lithuania in 2007 and the Gross enrolment ratio (%) in Malawi in 2010?
Make the answer very short. -36.88. What is the difference between the Gross enrolment ratio (%) in Caribbean small states in 2007 and the Gross enrolment ratio (%) in Argentina in 2011?
Keep it short and to the point. -21.63. What is the difference between the Gross enrolment ratio (%) of Caribbean small states in 2007 and the Gross enrolment ratio (%) of Lithuania in 2011?
Your answer should be very brief. -3.39. What is the difference between the Gross enrolment ratio (%) in Caribbean small states in 2007 and the Gross enrolment ratio (%) in Malawi in 2011?
Make the answer very short. -44.21. What is the difference between the Gross enrolment ratio (%) in Argentina in 2007 and the Gross enrolment ratio (%) in Lithuania in 2011?
Provide a succinct answer. 16.34. What is the difference between the Gross enrolment ratio (%) in Argentina in 2007 and the Gross enrolment ratio (%) in Malawi in 2011?
Offer a terse response. -24.48. What is the difference between the Gross enrolment ratio (%) in Lithuania in 2007 and the Gross enrolment ratio (%) in Malawi in 2011?
Your answer should be compact. -39.34. What is the difference between the Gross enrolment ratio (%) in Caribbean small states in 2007 and the Gross enrolment ratio (%) in Argentina in 2012?
Ensure brevity in your answer.  -27.81. What is the difference between the Gross enrolment ratio (%) in Caribbean small states in 2007 and the Gross enrolment ratio (%) in Lithuania in 2012?
Your answer should be very brief. -2.84. What is the difference between the Gross enrolment ratio (%) in Caribbean small states in 2007 and the Gross enrolment ratio (%) in Malawi in 2012?
Give a very brief answer. -45.35. What is the difference between the Gross enrolment ratio (%) of Argentina in 2007 and the Gross enrolment ratio (%) of Lithuania in 2012?
Give a very brief answer. 16.89. What is the difference between the Gross enrolment ratio (%) in Argentina in 2007 and the Gross enrolment ratio (%) in Malawi in 2012?
Your answer should be compact. -25.62. What is the difference between the Gross enrolment ratio (%) of Lithuania in 2007 and the Gross enrolment ratio (%) of Malawi in 2012?
Your response must be concise. -40.48. What is the difference between the Gross enrolment ratio (%) of Caribbean small states in 2008 and the Gross enrolment ratio (%) of Argentina in 2009?
Provide a short and direct response. -20.37. What is the difference between the Gross enrolment ratio (%) of Caribbean small states in 2008 and the Gross enrolment ratio (%) of Lithuania in 2009?
Your answer should be compact. -5.14. What is the difference between the Gross enrolment ratio (%) in Caribbean small states in 2008 and the Gross enrolment ratio (%) in Malawi in 2009?
Offer a terse response. -33.73. What is the difference between the Gross enrolment ratio (%) of Argentina in 2008 and the Gross enrolment ratio (%) of Lithuania in 2009?
Your response must be concise. 14.61. What is the difference between the Gross enrolment ratio (%) of Argentina in 2008 and the Gross enrolment ratio (%) of Malawi in 2009?
Provide a succinct answer. -13.98. What is the difference between the Gross enrolment ratio (%) of Lithuania in 2008 and the Gross enrolment ratio (%) of Malawi in 2009?
Provide a short and direct response. -29.64. What is the difference between the Gross enrolment ratio (%) in Caribbean small states in 2008 and the Gross enrolment ratio (%) in Argentina in 2010?
Give a very brief answer. -21.21. What is the difference between the Gross enrolment ratio (%) in Caribbean small states in 2008 and the Gross enrolment ratio (%) in Lithuania in 2010?
Give a very brief answer. -4.3. What is the difference between the Gross enrolment ratio (%) in Caribbean small states in 2008 and the Gross enrolment ratio (%) in Malawi in 2010?
Keep it short and to the point. -40.47. What is the difference between the Gross enrolment ratio (%) of Argentina in 2008 and the Gross enrolment ratio (%) of Lithuania in 2010?
Your answer should be very brief. 15.44. What is the difference between the Gross enrolment ratio (%) of Argentina in 2008 and the Gross enrolment ratio (%) of Malawi in 2010?
Offer a terse response. -20.72. What is the difference between the Gross enrolment ratio (%) of Lithuania in 2008 and the Gross enrolment ratio (%) of Malawi in 2010?
Offer a very short reply. -36.38. What is the difference between the Gross enrolment ratio (%) of Caribbean small states in 2008 and the Gross enrolment ratio (%) of Argentina in 2011?
Offer a terse response. -20.35. What is the difference between the Gross enrolment ratio (%) in Caribbean small states in 2008 and the Gross enrolment ratio (%) in Lithuania in 2011?
Offer a terse response. -2.11. What is the difference between the Gross enrolment ratio (%) in Caribbean small states in 2008 and the Gross enrolment ratio (%) in Malawi in 2011?
Your answer should be very brief. -42.93. What is the difference between the Gross enrolment ratio (%) of Argentina in 2008 and the Gross enrolment ratio (%) of Lithuania in 2011?
Make the answer very short. 17.63. What is the difference between the Gross enrolment ratio (%) in Argentina in 2008 and the Gross enrolment ratio (%) in Malawi in 2011?
Keep it short and to the point. -23.19. What is the difference between the Gross enrolment ratio (%) of Lithuania in 2008 and the Gross enrolment ratio (%) of Malawi in 2011?
Your answer should be very brief. -38.85. What is the difference between the Gross enrolment ratio (%) of Caribbean small states in 2008 and the Gross enrolment ratio (%) of Argentina in 2012?
Your answer should be very brief. -26.53. What is the difference between the Gross enrolment ratio (%) of Caribbean small states in 2008 and the Gross enrolment ratio (%) of Lithuania in 2012?
Your answer should be very brief. -1.56. What is the difference between the Gross enrolment ratio (%) in Caribbean small states in 2008 and the Gross enrolment ratio (%) in Malawi in 2012?
Provide a succinct answer. -44.07. What is the difference between the Gross enrolment ratio (%) in Argentina in 2008 and the Gross enrolment ratio (%) in Lithuania in 2012?
Make the answer very short. 18.18. What is the difference between the Gross enrolment ratio (%) of Argentina in 2008 and the Gross enrolment ratio (%) of Malawi in 2012?
Keep it short and to the point. -24.33. What is the difference between the Gross enrolment ratio (%) of Lithuania in 2008 and the Gross enrolment ratio (%) of Malawi in 2012?
Provide a short and direct response. -39.98. What is the difference between the Gross enrolment ratio (%) in Caribbean small states in 2009 and the Gross enrolment ratio (%) in Argentina in 2010?
Provide a short and direct response. -21.56. What is the difference between the Gross enrolment ratio (%) of Caribbean small states in 2009 and the Gross enrolment ratio (%) of Lithuania in 2010?
Provide a succinct answer. -4.65. What is the difference between the Gross enrolment ratio (%) of Caribbean small states in 2009 and the Gross enrolment ratio (%) of Malawi in 2010?
Your answer should be very brief. -40.81. What is the difference between the Gross enrolment ratio (%) of Argentina in 2009 and the Gross enrolment ratio (%) of Lithuania in 2010?
Provide a short and direct response. 16.07. What is the difference between the Gross enrolment ratio (%) in Argentina in 2009 and the Gross enrolment ratio (%) in Malawi in 2010?
Give a very brief answer. -20.1. What is the difference between the Gross enrolment ratio (%) of Lithuania in 2009 and the Gross enrolment ratio (%) of Malawi in 2010?
Provide a succinct answer. -35.33. What is the difference between the Gross enrolment ratio (%) in Caribbean small states in 2009 and the Gross enrolment ratio (%) in Argentina in 2011?
Ensure brevity in your answer.  -20.69. What is the difference between the Gross enrolment ratio (%) in Caribbean small states in 2009 and the Gross enrolment ratio (%) in Lithuania in 2011?
Provide a succinct answer. -2.46. What is the difference between the Gross enrolment ratio (%) of Caribbean small states in 2009 and the Gross enrolment ratio (%) of Malawi in 2011?
Provide a succinct answer. -43.28. What is the difference between the Gross enrolment ratio (%) of Argentina in 2009 and the Gross enrolment ratio (%) of Lithuania in 2011?
Provide a short and direct response. 18.26. What is the difference between the Gross enrolment ratio (%) of Argentina in 2009 and the Gross enrolment ratio (%) of Malawi in 2011?
Keep it short and to the point. -22.56. What is the difference between the Gross enrolment ratio (%) in Lithuania in 2009 and the Gross enrolment ratio (%) in Malawi in 2011?
Make the answer very short. -37.8. What is the difference between the Gross enrolment ratio (%) in Caribbean small states in 2009 and the Gross enrolment ratio (%) in Argentina in 2012?
Make the answer very short. -26.87. What is the difference between the Gross enrolment ratio (%) in Caribbean small states in 2009 and the Gross enrolment ratio (%) in Lithuania in 2012?
Your answer should be very brief. -1.9. What is the difference between the Gross enrolment ratio (%) in Caribbean small states in 2009 and the Gross enrolment ratio (%) in Malawi in 2012?
Ensure brevity in your answer.  -44.41. What is the difference between the Gross enrolment ratio (%) of Argentina in 2009 and the Gross enrolment ratio (%) of Lithuania in 2012?
Provide a succinct answer. 18.81. What is the difference between the Gross enrolment ratio (%) of Argentina in 2009 and the Gross enrolment ratio (%) of Malawi in 2012?
Give a very brief answer. -23.7. What is the difference between the Gross enrolment ratio (%) of Lithuania in 2009 and the Gross enrolment ratio (%) of Malawi in 2012?
Your answer should be very brief. -38.93. What is the difference between the Gross enrolment ratio (%) of Caribbean small states in 2010 and the Gross enrolment ratio (%) of Argentina in 2011?
Offer a very short reply. -21.83. What is the difference between the Gross enrolment ratio (%) in Caribbean small states in 2010 and the Gross enrolment ratio (%) in Lithuania in 2011?
Provide a succinct answer. -3.6. What is the difference between the Gross enrolment ratio (%) in Caribbean small states in 2010 and the Gross enrolment ratio (%) in Malawi in 2011?
Your answer should be very brief. -44.42. What is the difference between the Gross enrolment ratio (%) of Argentina in 2010 and the Gross enrolment ratio (%) of Lithuania in 2011?
Offer a very short reply. 19.1. What is the difference between the Gross enrolment ratio (%) of Argentina in 2010 and the Gross enrolment ratio (%) of Malawi in 2011?
Make the answer very short. -21.72. What is the difference between the Gross enrolment ratio (%) in Lithuania in 2010 and the Gross enrolment ratio (%) in Malawi in 2011?
Ensure brevity in your answer.  -38.63. What is the difference between the Gross enrolment ratio (%) in Caribbean small states in 2010 and the Gross enrolment ratio (%) in Argentina in 2012?
Provide a short and direct response. -28.01. What is the difference between the Gross enrolment ratio (%) in Caribbean small states in 2010 and the Gross enrolment ratio (%) in Lithuania in 2012?
Keep it short and to the point. -3.04. What is the difference between the Gross enrolment ratio (%) in Caribbean small states in 2010 and the Gross enrolment ratio (%) in Malawi in 2012?
Keep it short and to the point. -45.56. What is the difference between the Gross enrolment ratio (%) of Argentina in 2010 and the Gross enrolment ratio (%) of Lithuania in 2012?
Your response must be concise. 19.65. What is the difference between the Gross enrolment ratio (%) of Argentina in 2010 and the Gross enrolment ratio (%) of Malawi in 2012?
Your response must be concise. -22.86. What is the difference between the Gross enrolment ratio (%) in Lithuania in 2010 and the Gross enrolment ratio (%) in Malawi in 2012?
Offer a very short reply. -39.77. What is the difference between the Gross enrolment ratio (%) of Caribbean small states in 2011 and the Gross enrolment ratio (%) of Argentina in 2012?
Offer a terse response. -27.4. What is the difference between the Gross enrolment ratio (%) of Caribbean small states in 2011 and the Gross enrolment ratio (%) of Lithuania in 2012?
Offer a terse response. -2.44. What is the difference between the Gross enrolment ratio (%) of Caribbean small states in 2011 and the Gross enrolment ratio (%) of Malawi in 2012?
Your answer should be compact. -44.95. What is the difference between the Gross enrolment ratio (%) in Argentina in 2011 and the Gross enrolment ratio (%) in Lithuania in 2012?
Provide a succinct answer. 18.79. What is the difference between the Gross enrolment ratio (%) of Argentina in 2011 and the Gross enrolment ratio (%) of Malawi in 2012?
Your answer should be very brief. -23.73. What is the difference between the Gross enrolment ratio (%) of Lithuania in 2011 and the Gross enrolment ratio (%) of Malawi in 2012?
Make the answer very short. -41.96. What is the average Gross enrolment ratio (%) in Caribbean small states per year?
Provide a short and direct response. 97.42. What is the average Gross enrolment ratio (%) in Argentina per year?
Give a very brief answer. 117.21. What is the average Gross enrolment ratio (%) in Lithuania per year?
Your response must be concise. 100.04. What is the average Gross enrolment ratio (%) in Malawi per year?
Make the answer very short. 132.47. In the year 2005, what is the difference between the Gross enrolment ratio (%) in Caribbean small states and Gross enrolment ratio (%) in Argentina?
Your response must be concise. -12.93. In the year 2005, what is the difference between the Gross enrolment ratio (%) in Caribbean small states and Gross enrolment ratio (%) in Lithuania?
Your response must be concise. 2.82. In the year 2005, what is the difference between the Gross enrolment ratio (%) of Caribbean small states and Gross enrolment ratio (%) of Malawi?
Give a very brief answer. -26.64. In the year 2005, what is the difference between the Gross enrolment ratio (%) in Argentina and Gross enrolment ratio (%) in Lithuania?
Make the answer very short. 15.75. In the year 2005, what is the difference between the Gross enrolment ratio (%) of Argentina and Gross enrolment ratio (%) of Malawi?
Ensure brevity in your answer.  -13.71. In the year 2005, what is the difference between the Gross enrolment ratio (%) of Lithuania and Gross enrolment ratio (%) of Malawi?
Offer a very short reply. -29.46. In the year 2006, what is the difference between the Gross enrolment ratio (%) of Caribbean small states and Gross enrolment ratio (%) of Argentina?
Your answer should be compact. -14.14. In the year 2006, what is the difference between the Gross enrolment ratio (%) of Caribbean small states and Gross enrolment ratio (%) of Lithuania?
Make the answer very short. 1.56. In the year 2006, what is the difference between the Gross enrolment ratio (%) of Caribbean small states and Gross enrolment ratio (%) of Malawi?
Your answer should be very brief. -26.31. In the year 2006, what is the difference between the Gross enrolment ratio (%) of Argentina and Gross enrolment ratio (%) of Lithuania?
Offer a very short reply. 15.7. In the year 2006, what is the difference between the Gross enrolment ratio (%) in Argentina and Gross enrolment ratio (%) in Malawi?
Keep it short and to the point. -12.17. In the year 2006, what is the difference between the Gross enrolment ratio (%) of Lithuania and Gross enrolment ratio (%) of Malawi?
Your answer should be very brief. -27.88. In the year 2007, what is the difference between the Gross enrolment ratio (%) in Caribbean small states and Gross enrolment ratio (%) in Argentina?
Ensure brevity in your answer.  -19.73. In the year 2007, what is the difference between the Gross enrolment ratio (%) in Caribbean small states and Gross enrolment ratio (%) in Lithuania?
Offer a terse response. -4.87. In the year 2007, what is the difference between the Gross enrolment ratio (%) of Caribbean small states and Gross enrolment ratio (%) of Malawi?
Ensure brevity in your answer.  -28.29. In the year 2007, what is the difference between the Gross enrolment ratio (%) in Argentina and Gross enrolment ratio (%) in Lithuania?
Your response must be concise. 14.86. In the year 2007, what is the difference between the Gross enrolment ratio (%) of Argentina and Gross enrolment ratio (%) of Malawi?
Give a very brief answer. -8.55. In the year 2007, what is the difference between the Gross enrolment ratio (%) in Lithuania and Gross enrolment ratio (%) in Malawi?
Give a very brief answer. -23.42. In the year 2008, what is the difference between the Gross enrolment ratio (%) in Caribbean small states and Gross enrolment ratio (%) in Argentina?
Give a very brief answer. -19.74. In the year 2008, what is the difference between the Gross enrolment ratio (%) in Caribbean small states and Gross enrolment ratio (%) in Lithuania?
Ensure brevity in your answer.  -4.09. In the year 2008, what is the difference between the Gross enrolment ratio (%) in Caribbean small states and Gross enrolment ratio (%) in Malawi?
Make the answer very short. -34.68. In the year 2008, what is the difference between the Gross enrolment ratio (%) of Argentina and Gross enrolment ratio (%) of Lithuania?
Keep it short and to the point. 15.66. In the year 2008, what is the difference between the Gross enrolment ratio (%) in Argentina and Gross enrolment ratio (%) in Malawi?
Your answer should be very brief. -14.93. In the year 2008, what is the difference between the Gross enrolment ratio (%) of Lithuania and Gross enrolment ratio (%) of Malawi?
Give a very brief answer. -30.59. In the year 2009, what is the difference between the Gross enrolment ratio (%) of Caribbean small states and Gross enrolment ratio (%) of Argentina?
Your answer should be very brief. -20.71. In the year 2009, what is the difference between the Gross enrolment ratio (%) in Caribbean small states and Gross enrolment ratio (%) in Lithuania?
Offer a terse response. -5.48. In the year 2009, what is the difference between the Gross enrolment ratio (%) in Caribbean small states and Gross enrolment ratio (%) in Malawi?
Ensure brevity in your answer.  -34.07. In the year 2009, what is the difference between the Gross enrolment ratio (%) in Argentina and Gross enrolment ratio (%) in Lithuania?
Ensure brevity in your answer.  15.23. In the year 2009, what is the difference between the Gross enrolment ratio (%) in Argentina and Gross enrolment ratio (%) in Malawi?
Ensure brevity in your answer.  -13.36. In the year 2009, what is the difference between the Gross enrolment ratio (%) in Lithuania and Gross enrolment ratio (%) in Malawi?
Offer a very short reply. -28.59. In the year 2010, what is the difference between the Gross enrolment ratio (%) in Caribbean small states and Gross enrolment ratio (%) in Argentina?
Your answer should be very brief. -22.7. In the year 2010, what is the difference between the Gross enrolment ratio (%) of Caribbean small states and Gross enrolment ratio (%) of Lithuania?
Provide a succinct answer. -5.79. In the year 2010, what is the difference between the Gross enrolment ratio (%) of Caribbean small states and Gross enrolment ratio (%) of Malawi?
Your answer should be compact. -41.95. In the year 2010, what is the difference between the Gross enrolment ratio (%) of Argentina and Gross enrolment ratio (%) of Lithuania?
Make the answer very short. 16.91. In the year 2010, what is the difference between the Gross enrolment ratio (%) in Argentina and Gross enrolment ratio (%) in Malawi?
Your response must be concise. -19.25. In the year 2010, what is the difference between the Gross enrolment ratio (%) in Lithuania and Gross enrolment ratio (%) in Malawi?
Your response must be concise. -36.17. In the year 2011, what is the difference between the Gross enrolment ratio (%) of Caribbean small states and Gross enrolment ratio (%) of Argentina?
Your answer should be compact. -21.22. In the year 2011, what is the difference between the Gross enrolment ratio (%) of Caribbean small states and Gross enrolment ratio (%) of Lithuania?
Your answer should be compact. -2.99. In the year 2011, what is the difference between the Gross enrolment ratio (%) in Caribbean small states and Gross enrolment ratio (%) in Malawi?
Your response must be concise. -43.81. In the year 2011, what is the difference between the Gross enrolment ratio (%) of Argentina and Gross enrolment ratio (%) of Lithuania?
Your answer should be compact. 18.23. In the year 2011, what is the difference between the Gross enrolment ratio (%) in Argentina and Gross enrolment ratio (%) in Malawi?
Provide a succinct answer. -22.59. In the year 2011, what is the difference between the Gross enrolment ratio (%) in Lithuania and Gross enrolment ratio (%) in Malawi?
Your answer should be very brief. -40.82. In the year 2012, what is the difference between the Gross enrolment ratio (%) of Caribbean small states and Gross enrolment ratio (%) of Argentina?
Provide a succinct answer. -27.09. In the year 2012, what is the difference between the Gross enrolment ratio (%) of Caribbean small states and Gross enrolment ratio (%) of Lithuania?
Make the answer very short. -2.13. In the year 2012, what is the difference between the Gross enrolment ratio (%) of Caribbean small states and Gross enrolment ratio (%) of Malawi?
Offer a very short reply. -44.64. In the year 2012, what is the difference between the Gross enrolment ratio (%) of Argentina and Gross enrolment ratio (%) of Lithuania?
Provide a succinct answer. 24.97. In the year 2012, what is the difference between the Gross enrolment ratio (%) in Argentina and Gross enrolment ratio (%) in Malawi?
Provide a short and direct response. -17.55. In the year 2012, what is the difference between the Gross enrolment ratio (%) in Lithuania and Gross enrolment ratio (%) in Malawi?
Your response must be concise. -42.51. What is the ratio of the Gross enrolment ratio (%) of Argentina in 2005 to that in 2006?
Make the answer very short. 0.99. What is the ratio of the Gross enrolment ratio (%) of Lithuania in 2005 to that in 2006?
Give a very brief answer. 0.98. What is the ratio of the Gross enrolment ratio (%) in Caribbean small states in 2005 to that in 2007?
Your answer should be very brief. 1.04. What is the ratio of the Gross enrolment ratio (%) in Argentina in 2005 to that in 2007?
Keep it short and to the point. 0.98. What is the ratio of the Gross enrolment ratio (%) of Lithuania in 2005 to that in 2007?
Give a very brief answer. 0.97. What is the ratio of the Gross enrolment ratio (%) of Malawi in 2005 to that in 2007?
Offer a terse response. 1.02. What is the ratio of the Gross enrolment ratio (%) in Caribbean small states in 2005 to that in 2008?
Provide a succinct answer. 1.03. What is the ratio of the Gross enrolment ratio (%) of Argentina in 2005 to that in 2008?
Make the answer very short. 0.97. What is the ratio of the Gross enrolment ratio (%) in Malawi in 2005 to that in 2008?
Offer a very short reply. 0.96. What is the ratio of the Gross enrolment ratio (%) in Caribbean small states in 2005 to that in 2009?
Offer a very short reply. 1.03. What is the ratio of the Gross enrolment ratio (%) in Argentina in 2005 to that in 2009?
Provide a short and direct response. 0.96. What is the ratio of the Gross enrolment ratio (%) of Lithuania in 2005 to that in 2009?
Offer a terse response. 0.95. What is the ratio of the Gross enrolment ratio (%) in Malawi in 2005 to that in 2009?
Give a very brief answer. 0.97. What is the ratio of the Gross enrolment ratio (%) in Caribbean small states in 2005 to that in 2010?
Provide a short and direct response. 1.05. What is the ratio of the Gross enrolment ratio (%) in Argentina in 2005 to that in 2010?
Provide a short and direct response. 0.96. What is the ratio of the Gross enrolment ratio (%) of Malawi in 2005 to that in 2010?
Make the answer very short. 0.92. What is the ratio of the Gross enrolment ratio (%) in Caribbean small states in 2005 to that in 2011?
Your answer should be very brief. 1.04. What is the ratio of the Gross enrolment ratio (%) in Argentina in 2005 to that in 2011?
Provide a succinct answer. 0.96. What is the ratio of the Gross enrolment ratio (%) of Lithuania in 2005 to that in 2011?
Offer a terse response. 0.98. What is the ratio of the Gross enrolment ratio (%) of Malawi in 2005 to that in 2011?
Make the answer very short. 0.9. What is the ratio of the Gross enrolment ratio (%) of Caribbean small states in 2005 to that in 2012?
Make the answer very short. 1.04. What is the ratio of the Gross enrolment ratio (%) of Argentina in 2005 to that in 2012?
Your answer should be compact. 0.91. What is the ratio of the Gross enrolment ratio (%) in Lithuania in 2005 to that in 2012?
Your response must be concise. 0.99. What is the ratio of the Gross enrolment ratio (%) in Malawi in 2005 to that in 2012?
Keep it short and to the point. 0.9. What is the ratio of the Gross enrolment ratio (%) in Caribbean small states in 2006 to that in 2007?
Ensure brevity in your answer.  1.05. What is the ratio of the Gross enrolment ratio (%) in Argentina in 2006 to that in 2007?
Provide a succinct answer. 0.99. What is the ratio of the Gross enrolment ratio (%) in Lithuania in 2006 to that in 2007?
Keep it short and to the point. 0.98. What is the ratio of the Gross enrolment ratio (%) in Malawi in 2006 to that in 2007?
Provide a succinct answer. 1.02. What is the ratio of the Gross enrolment ratio (%) in Caribbean small states in 2006 to that in 2008?
Keep it short and to the point. 1.03. What is the ratio of the Gross enrolment ratio (%) of Argentina in 2006 to that in 2008?
Ensure brevity in your answer.  0.98. What is the ratio of the Gross enrolment ratio (%) in Lithuania in 2006 to that in 2008?
Offer a terse response. 0.98. What is the ratio of the Gross enrolment ratio (%) in Malawi in 2006 to that in 2008?
Your response must be concise. 0.96. What is the ratio of the Gross enrolment ratio (%) in Caribbean small states in 2006 to that in 2009?
Ensure brevity in your answer.  1.04. What is the ratio of the Gross enrolment ratio (%) in Argentina in 2006 to that in 2009?
Your response must be concise. 0.97. What is the ratio of the Gross enrolment ratio (%) of Lithuania in 2006 to that in 2009?
Provide a short and direct response. 0.97. What is the ratio of the Gross enrolment ratio (%) in Malawi in 2006 to that in 2009?
Keep it short and to the point. 0.97. What is the ratio of the Gross enrolment ratio (%) in Caribbean small states in 2006 to that in 2010?
Offer a very short reply. 1.05. What is the ratio of the Gross enrolment ratio (%) in Argentina in 2006 to that in 2010?
Your answer should be compact. 0.97. What is the ratio of the Gross enrolment ratio (%) of Lithuania in 2006 to that in 2010?
Provide a succinct answer. 0.97. What is the ratio of the Gross enrolment ratio (%) in Malawi in 2006 to that in 2010?
Ensure brevity in your answer.  0.92. What is the ratio of the Gross enrolment ratio (%) of Caribbean small states in 2006 to that in 2011?
Offer a very short reply. 1.04. What is the ratio of the Gross enrolment ratio (%) of Argentina in 2006 to that in 2011?
Provide a short and direct response. 0.97. What is the ratio of the Gross enrolment ratio (%) of Malawi in 2006 to that in 2011?
Make the answer very short. 0.9. What is the ratio of the Gross enrolment ratio (%) of Caribbean small states in 2006 to that in 2012?
Your answer should be very brief. 1.04. What is the ratio of the Gross enrolment ratio (%) in Argentina in 2006 to that in 2012?
Offer a very short reply. 0.93. What is the ratio of the Gross enrolment ratio (%) in Malawi in 2006 to that in 2012?
Provide a short and direct response. 0.9. What is the ratio of the Gross enrolment ratio (%) in Argentina in 2007 to that in 2008?
Offer a terse response. 0.99. What is the ratio of the Gross enrolment ratio (%) in Malawi in 2007 to that in 2008?
Keep it short and to the point. 0.94. What is the ratio of the Gross enrolment ratio (%) of Caribbean small states in 2007 to that in 2009?
Ensure brevity in your answer.  0.99. What is the ratio of the Gross enrolment ratio (%) in Argentina in 2007 to that in 2009?
Your answer should be compact. 0.98. What is the ratio of the Gross enrolment ratio (%) in Lithuania in 2007 to that in 2009?
Make the answer very short. 0.98. What is the ratio of the Gross enrolment ratio (%) in Malawi in 2007 to that in 2009?
Your answer should be very brief. 0.95. What is the ratio of the Gross enrolment ratio (%) of Argentina in 2007 to that in 2010?
Ensure brevity in your answer.  0.98. What is the ratio of the Gross enrolment ratio (%) of Malawi in 2007 to that in 2010?
Ensure brevity in your answer.  0.9. What is the ratio of the Gross enrolment ratio (%) in Argentina in 2007 to that in 2011?
Offer a very short reply. 0.98. What is the ratio of the Gross enrolment ratio (%) in Lithuania in 2007 to that in 2011?
Provide a succinct answer. 1.01. What is the ratio of the Gross enrolment ratio (%) of Malawi in 2007 to that in 2011?
Your answer should be very brief. 0.89. What is the ratio of the Gross enrolment ratio (%) of Argentina in 2007 to that in 2012?
Ensure brevity in your answer.  0.93. What is the ratio of the Gross enrolment ratio (%) of Lithuania in 2007 to that in 2012?
Provide a succinct answer. 1.02. What is the ratio of the Gross enrolment ratio (%) of Malawi in 2007 to that in 2012?
Your answer should be compact. 0.88. What is the ratio of the Gross enrolment ratio (%) in Caribbean small states in 2008 to that in 2009?
Make the answer very short. 1. What is the ratio of the Gross enrolment ratio (%) of Argentina in 2008 to that in 2009?
Your answer should be very brief. 0.99. What is the ratio of the Gross enrolment ratio (%) in Lithuania in 2008 to that in 2009?
Your response must be concise. 0.99. What is the ratio of the Gross enrolment ratio (%) in Malawi in 2008 to that in 2009?
Provide a short and direct response. 1.01. What is the ratio of the Gross enrolment ratio (%) in Caribbean small states in 2008 to that in 2010?
Offer a very short reply. 1.02. What is the ratio of the Gross enrolment ratio (%) in Argentina in 2008 to that in 2010?
Your answer should be compact. 0.99. What is the ratio of the Gross enrolment ratio (%) of Lithuania in 2008 to that in 2010?
Keep it short and to the point. 1. What is the ratio of the Gross enrolment ratio (%) of Malawi in 2008 to that in 2010?
Offer a terse response. 0.96. What is the ratio of the Gross enrolment ratio (%) in Caribbean small states in 2008 to that in 2011?
Provide a succinct answer. 1.01. What is the ratio of the Gross enrolment ratio (%) in Lithuania in 2008 to that in 2011?
Your response must be concise. 1.02. What is the ratio of the Gross enrolment ratio (%) in Malawi in 2008 to that in 2011?
Provide a short and direct response. 0.94. What is the ratio of the Gross enrolment ratio (%) of Caribbean small states in 2008 to that in 2012?
Make the answer very short. 1.01. What is the ratio of the Gross enrolment ratio (%) in Argentina in 2008 to that in 2012?
Make the answer very short. 0.95. What is the ratio of the Gross enrolment ratio (%) of Lithuania in 2008 to that in 2012?
Your answer should be compact. 1.03. What is the ratio of the Gross enrolment ratio (%) of Malawi in 2008 to that in 2012?
Provide a short and direct response. 0.93. What is the ratio of the Gross enrolment ratio (%) of Caribbean small states in 2009 to that in 2010?
Ensure brevity in your answer.  1.01. What is the ratio of the Gross enrolment ratio (%) of Argentina in 2009 to that in 2010?
Offer a very short reply. 0.99. What is the ratio of the Gross enrolment ratio (%) in Lithuania in 2009 to that in 2010?
Ensure brevity in your answer.  1.01. What is the ratio of the Gross enrolment ratio (%) in Malawi in 2009 to that in 2010?
Ensure brevity in your answer.  0.95. What is the ratio of the Gross enrolment ratio (%) in Argentina in 2009 to that in 2011?
Your response must be concise. 1. What is the ratio of the Gross enrolment ratio (%) in Lithuania in 2009 to that in 2011?
Offer a terse response. 1.03. What is the ratio of the Gross enrolment ratio (%) of Malawi in 2009 to that in 2011?
Give a very brief answer. 0.93. What is the ratio of the Gross enrolment ratio (%) in Caribbean small states in 2009 to that in 2012?
Your response must be concise. 1. What is the ratio of the Gross enrolment ratio (%) in Argentina in 2009 to that in 2012?
Your answer should be very brief. 0.95. What is the ratio of the Gross enrolment ratio (%) in Lithuania in 2009 to that in 2012?
Offer a very short reply. 1.04. What is the ratio of the Gross enrolment ratio (%) of Malawi in 2009 to that in 2012?
Your response must be concise. 0.93. What is the ratio of the Gross enrolment ratio (%) of Argentina in 2010 to that in 2011?
Provide a short and direct response. 1.01. What is the ratio of the Gross enrolment ratio (%) in Lithuania in 2010 to that in 2011?
Provide a short and direct response. 1.02. What is the ratio of the Gross enrolment ratio (%) in Malawi in 2010 to that in 2011?
Keep it short and to the point. 0.98. What is the ratio of the Gross enrolment ratio (%) in Caribbean small states in 2010 to that in 2012?
Provide a succinct answer. 0.99. What is the ratio of the Gross enrolment ratio (%) of Argentina in 2010 to that in 2012?
Keep it short and to the point. 0.96. What is the ratio of the Gross enrolment ratio (%) in Lithuania in 2010 to that in 2012?
Provide a short and direct response. 1.03. What is the ratio of the Gross enrolment ratio (%) of Malawi in 2010 to that in 2012?
Make the answer very short. 0.97. What is the ratio of the Gross enrolment ratio (%) of Argentina in 2011 to that in 2012?
Provide a short and direct response. 0.95. What is the ratio of the Gross enrolment ratio (%) in Lithuania in 2011 to that in 2012?
Make the answer very short. 1.01. What is the ratio of the Gross enrolment ratio (%) of Malawi in 2011 to that in 2012?
Offer a terse response. 0.99. What is the difference between the highest and the second highest Gross enrolment ratio (%) of Caribbean small states?
Keep it short and to the point. 0.23. What is the difference between the highest and the second highest Gross enrolment ratio (%) of Argentina?
Provide a short and direct response. 5.31. What is the difference between the highest and the second highest Gross enrolment ratio (%) of Lithuania?
Offer a very short reply. 0.83. What is the difference between the highest and the second highest Gross enrolment ratio (%) of Malawi?
Provide a short and direct response. 1.14. What is the difference between the highest and the lowest Gross enrolment ratio (%) in Caribbean small states?
Keep it short and to the point. 4.68. What is the difference between the highest and the lowest Gross enrolment ratio (%) of Argentina?
Offer a very short reply. 10.64. What is the difference between the highest and the lowest Gross enrolment ratio (%) in Lithuania?
Provide a succinct answer. 5. What is the difference between the highest and the lowest Gross enrolment ratio (%) in Malawi?
Your answer should be very brief. 17.06. 